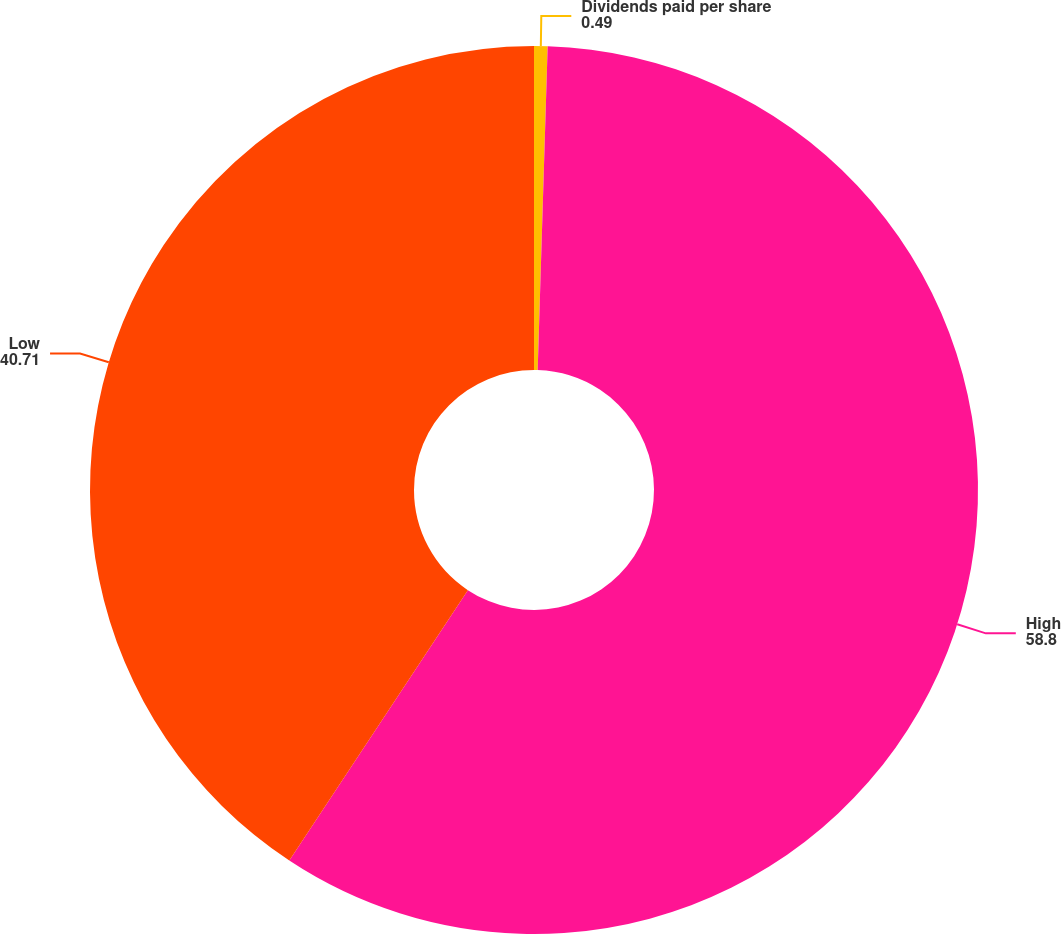Convert chart. <chart><loc_0><loc_0><loc_500><loc_500><pie_chart><fcel>Dividends paid per share<fcel>High<fcel>Low<nl><fcel>0.49%<fcel>58.8%<fcel>40.71%<nl></chart> 